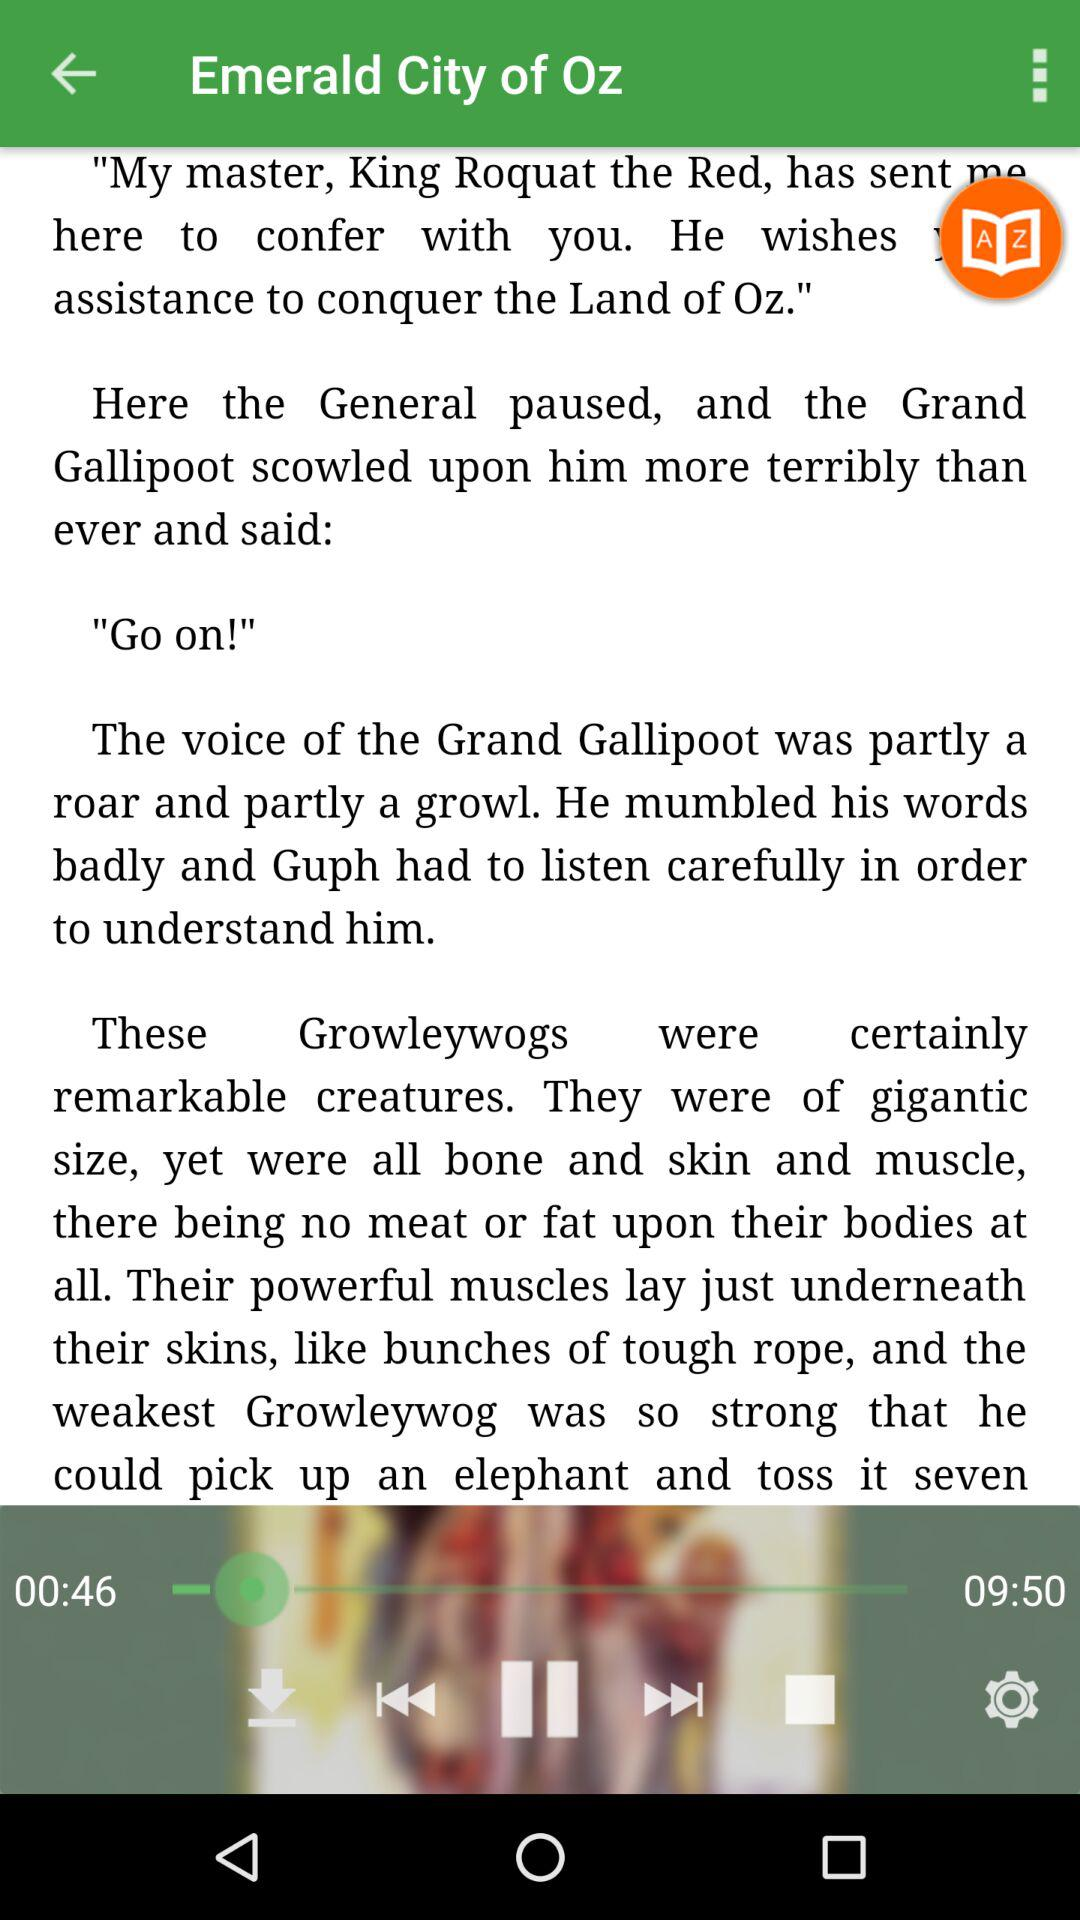For how long has the audio been played? The audio has been played for 46 seconds. 